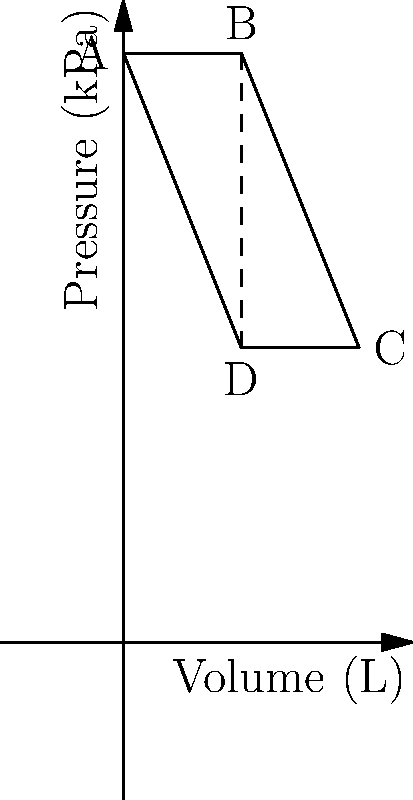The pressure-volume diagram above represents the respiratory cycle of a wild animal. Given that the work done by the respiratory muscles during inhalation is represented by the area enclosed by the curve, calculate the efficiency of the respiratory system if the total work done in one complete cycle is 15 J and the work done against elastic forces is 6 J. To calculate the efficiency of the respiratory system, we need to follow these steps:

1. Understand the components of work in the respiratory cycle:
   - Total work = Work against elastic forces + Work against resistive forces
   - Efficiency is related to the useful work done (against elastic forces) compared to the total work

2. Given information:
   - Total work in one complete cycle = 15 J
   - Work done against elastic forces = 6 J

3. Calculate the work done against resistive forces:
   Work against resistive forces = Total work - Work against elastic forces
   $15 J - 6 J = 9 J$

4. Calculate the efficiency:
   Efficiency = (Useful work / Total work) × 100%
   $\text{Efficiency} = \frac{\text{Work against elastic forces}}{\text{Total work}} \times 100\%$
   $\text{Efficiency} = \frac{6 J}{15 J} \times 100\% = 40\%$

The efficiency of the respiratory system is 40%, indicating that 40% of the total work done by the respiratory muscles is used to overcome elastic forces, while the remaining 60% is lost to overcome resistive forces.
Answer: 40% 